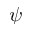Convert formula to latex. <formula><loc_0><loc_0><loc_500><loc_500>\psi</formula> 